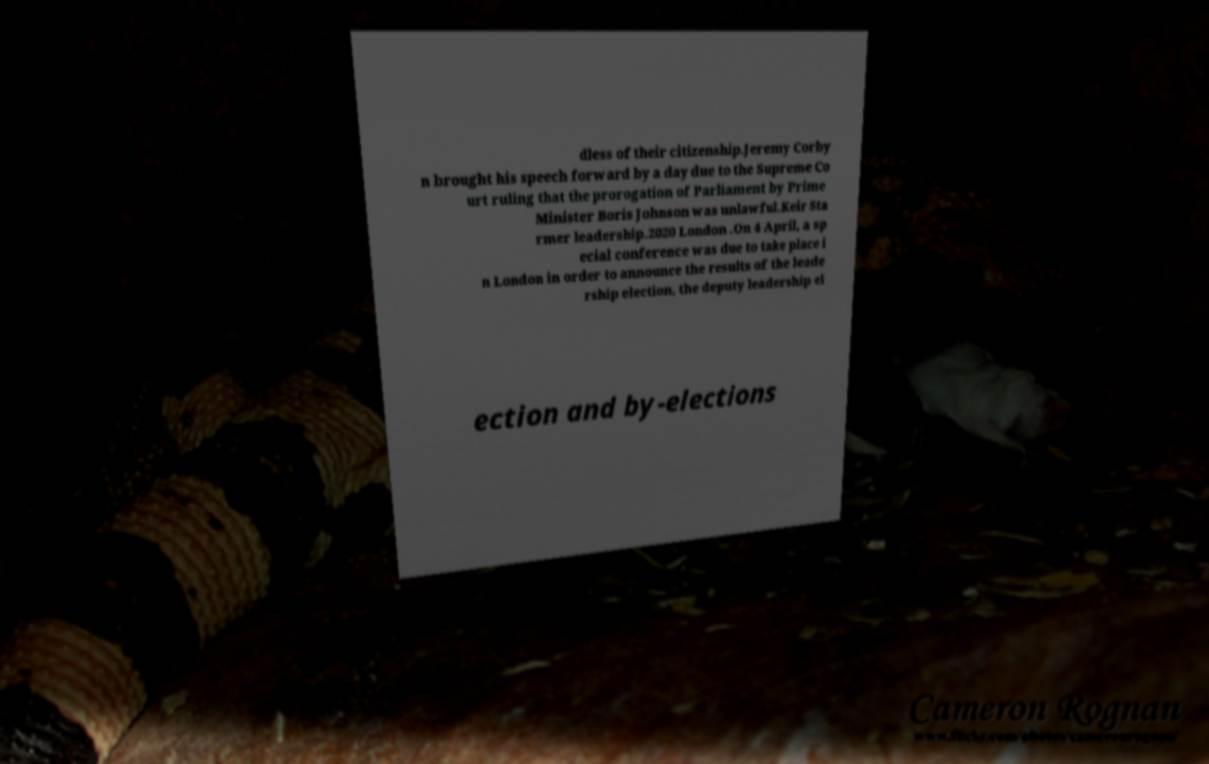Please identify and transcribe the text found in this image. dless of their citizenship.Jeremy Corby n brought his speech forward by a day due to the Supreme Co urt ruling that the prorogation of Parliament by Prime Minister Boris Johnson was unlawful.Keir Sta rmer leadership.2020 London .On 4 April, a sp ecial conference was due to take place i n London in order to announce the results of the leade rship election, the deputy leadership el ection and by-elections 